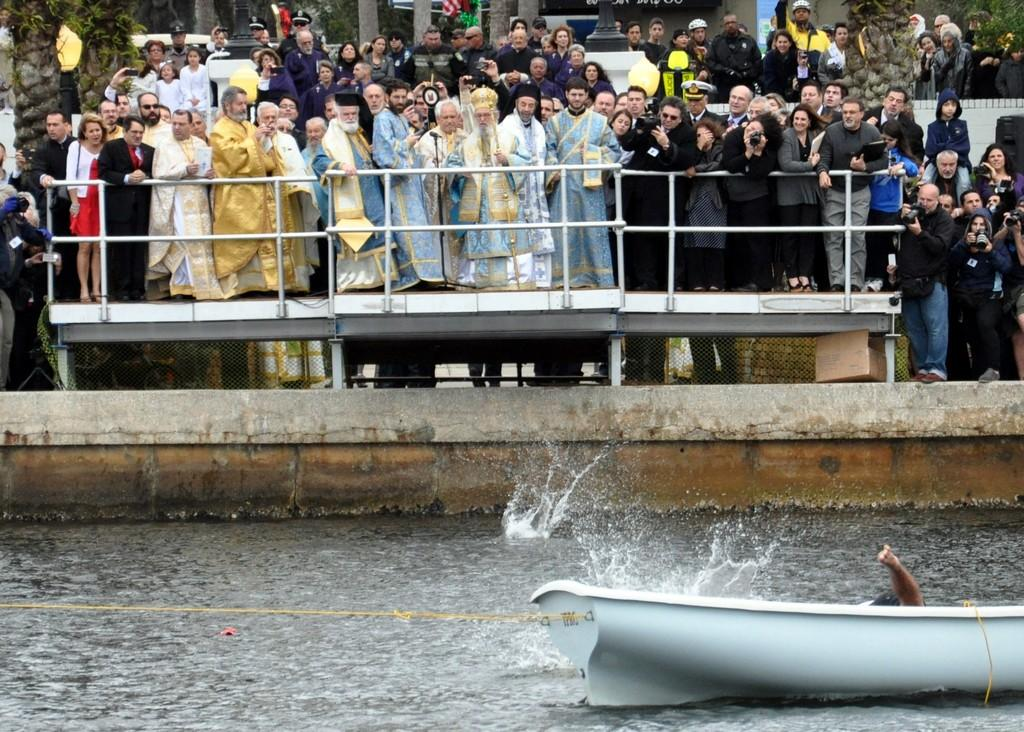What is the main feature of the image? There is water in the image. What is located on the water? There is a boat in the image. Are there any people present in the image? Yes, there are people standing in the image. What can be seen in the background of the image? There are buildings in the image. What are some people doing in the image? Some people are holding cameras in the image. How much sand can be seen on the boat in the image? There is no sand present on the boat in the image. Can you tell me how many friends are with the people holding cameras in the image? There is no mention of friends in the image; only people holding cameras are mentioned. 